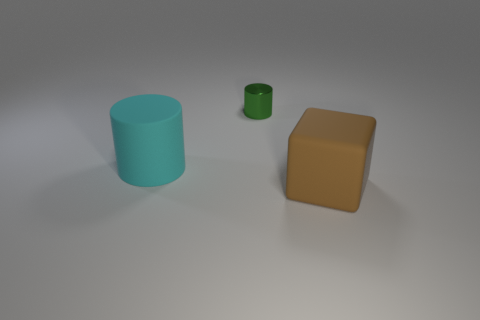Add 3 tiny gray matte cylinders. How many objects exist? 6 Subtract all cubes. How many objects are left? 2 Subtract 1 cyan cylinders. How many objects are left? 2 Subtract all yellow cylinders. Subtract all big matte cubes. How many objects are left? 2 Add 3 objects. How many objects are left? 6 Add 1 large red shiny things. How many large red shiny things exist? 1 